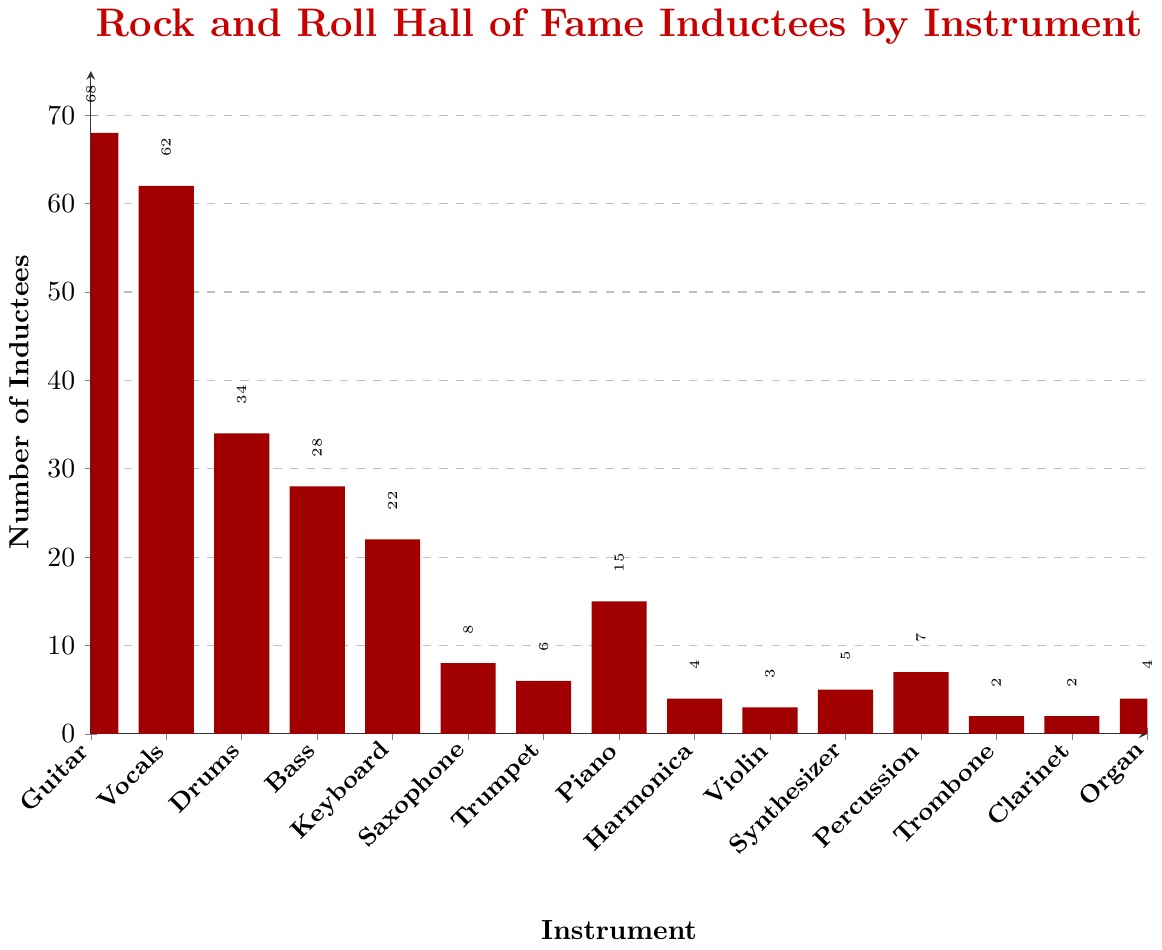What's the most common instrument played by Rock and Roll Hall of Fame inductees? The instrument with the highest bar in the chart indicates the most common instrument played by inductees. The bar representing 'Guitar' is the tallest, at 68 inductees.
Answer: Guitar Which instrument has more inductees, Saxophone or Trumpet? Compare the heights of the bars representing Saxophone and Trumpet. The Saxophone bar represents 8 inductees and the Trumpet bar represents 6 inductees.
Answer: Saxophone What is the total number of inductees for the instruments that have less than 10 inductees each? Identify the bars for instruments with fewer than 10 inductees: Saxophone (8), Trumpet (6), Harmonica (4), Violin (3), Synthesizer (5), Percussion (7), Trombone (2), Clarinet (2), Organ (4). Sum these values: 8+6+4+3+5+7+2+2+4 = 41.
Answer: 41 How many more inductees play Guitar than play Bass? Find the number of inductees for both Guitar (68) and Bass (28). Subtract the number for Bass from the number for Guitar: 68 - 28 = 40.
Answer: 40 Which instrument has exactly twice the number of inductees as Synthesizer? The Synthesizer has 5 inductees. An instrument with twice this number would have 5 * 2 = 10 inductees. No instrument has exactly this number of inductees.
Answer: None What is the range in the number of inductees across all instruments? Find the maximum and minimum values in the chart. The maximum is 68 (Guitar) and the minimum is 2 (Trombone and Clarinet). The range is 68 - 2 = 66.
Answer: 66 Which instrument category has the fewest inductees in the Rock and Roll Hall of Fame? The shortest bars in the chart represent the instruments with the fewest inductees. Trombone and Clarinet both have 2 inductees, which is the smallest number.
Answer: Trombone and Clarinet How many inductees play a keyboard-related instrument (Keyboard, Organ, and Piano)? Sum the number of inductees for Keyboard (22), Organ (4), and Piano (15): 22 + 4 + 15 = 41.
Answer: 41 What's the combined number of vocalists and guitarists in the Rock and Roll Hall of Fame? Sum the number of inductees for Vocals (62) and Guitar (68): 68 + 62 = 130.
Answer: 130 Which instrument is represented by a bar with a height between the number of inductees for Drums and Bass? Drums has 34 inductees and Bass has 28 inductees. The value between 28 and 34 is 22, which corresponds to the Keyboard.
Answer: Keyboard 